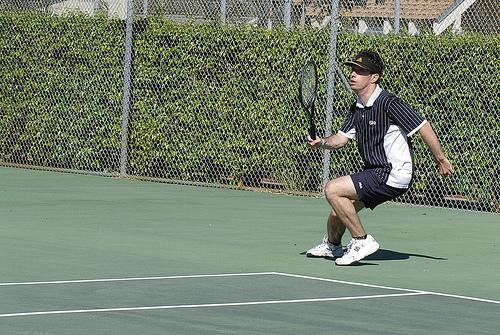How many people are shown?
Give a very brief answer. 1. 